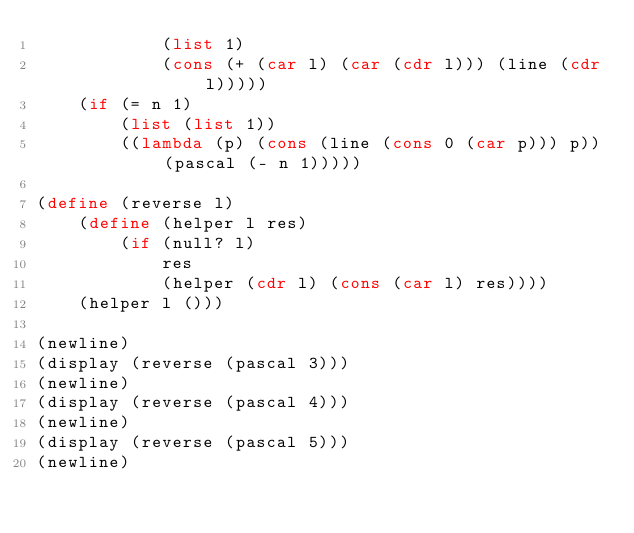<code> <loc_0><loc_0><loc_500><loc_500><_Scheme_>            (list 1)
            (cons (+ (car l) (car (cdr l))) (line (cdr l)))))
    (if (= n 1)
        (list (list 1))
        ((lambda (p) (cons (line (cons 0 (car p))) p)) (pascal (- n 1)))))

(define (reverse l)
    (define (helper l res)
        (if (null? l)
            res
            (helper (cdr l) (cons (car l) res))))
    (helper l ()))

(newline)
(display (reverse (pascal 3)))
(newline)
(display (reverse (pascal 4)))
(newline)
(display (reverse (pascal 5)))
(newline)
</code> 